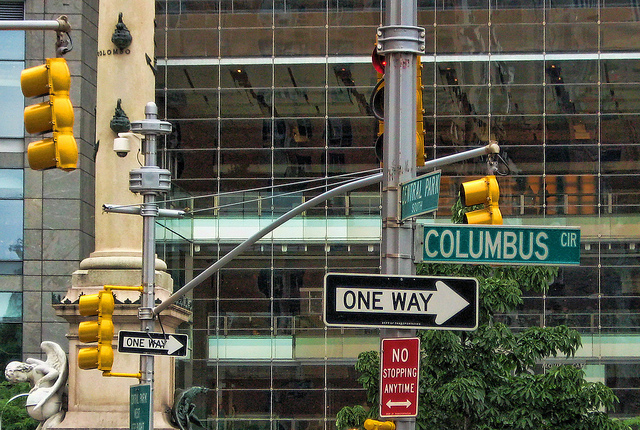Please transcribe the text in this image. PARK COLUMBUS ONE WAY ONE CIR ANYTIME STOPPING NO WAY 